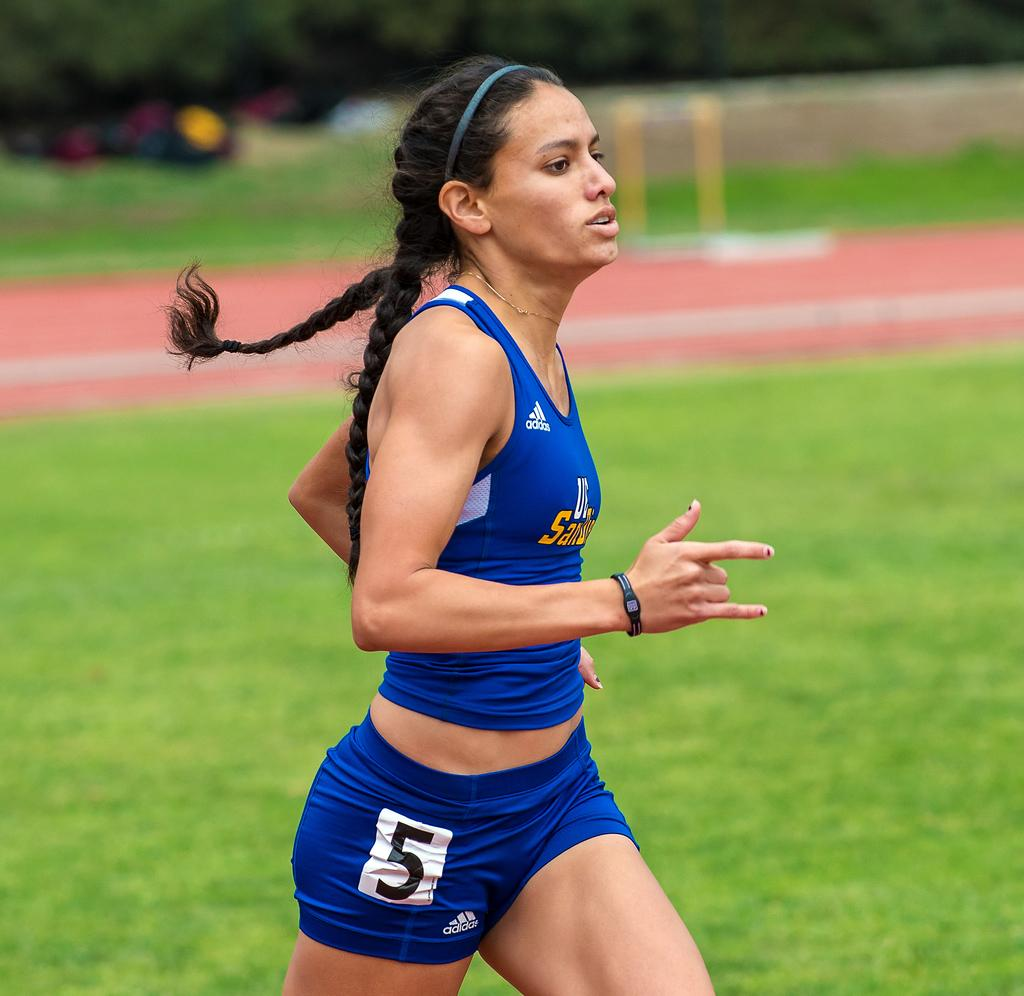<image>
Offer a succinct explanation of the picture presented. The female runner pictured is wearing a top and bottoms made by adidas. 